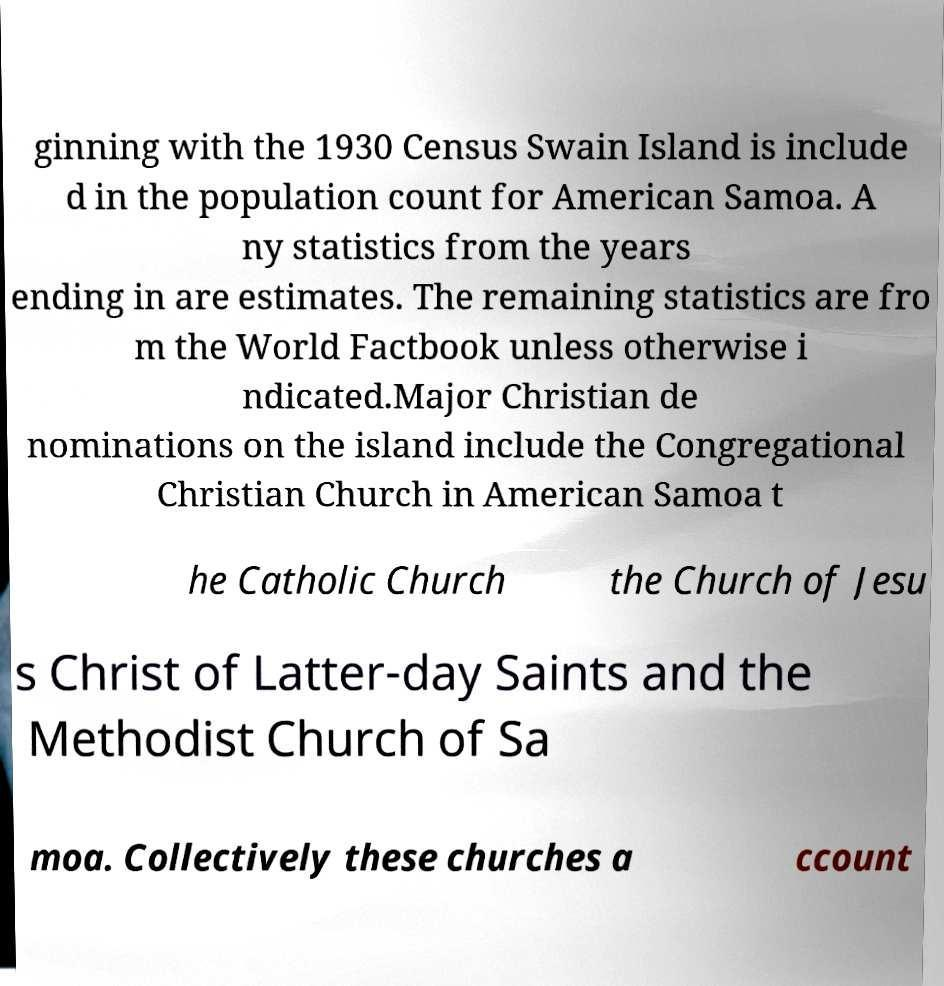Can you accurately transcribe the text from the provided image for me? ginning with the 1930 Census Swain Island is include d in the population count for American Samoa. A ny statistics from the years ending in are estimates. The remaining statistics are fro m the World Factbook unless otherwise i ndicated.Major Christian de nominations on the island include the Congregational Christian Church in American Samoa t he Catholic Church the Church of Jesu s Christ of Latter-day Saints and the Methodist Church of Sa moa. Collectively these churches a ccount 